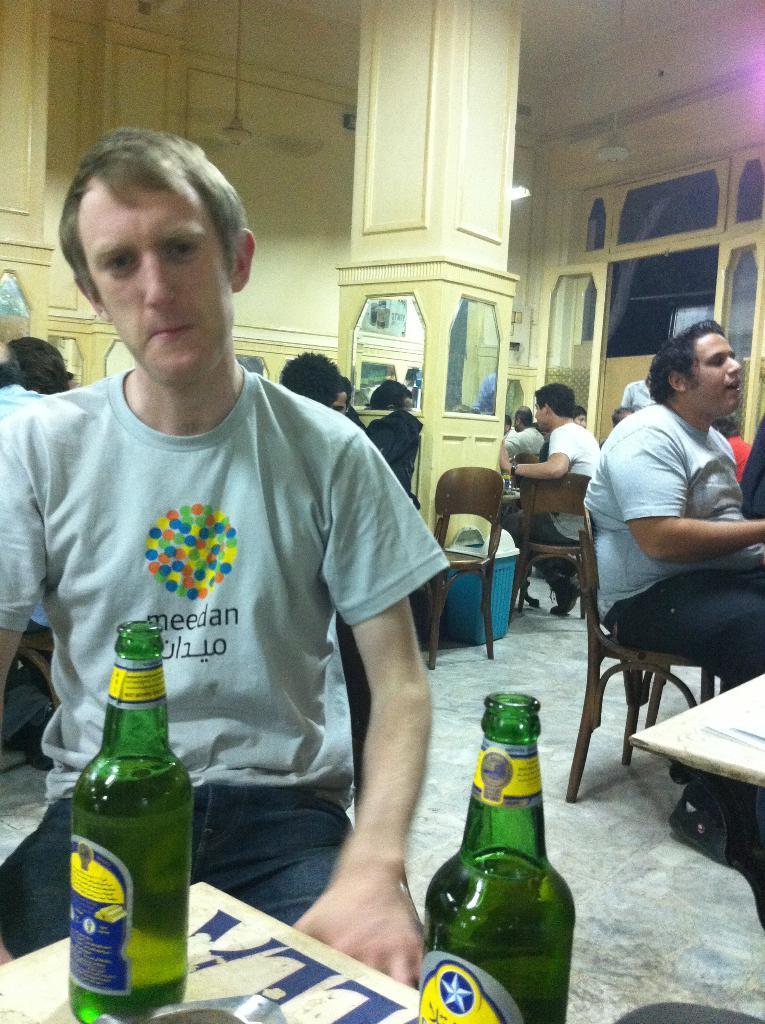Can you describe this image briefly? here in this picture we can see a room in which people are sitting in a chair in front of a table having a bottle,here we can see the bottles on the table,here we can also see the glass ,light and fan on the roof. 